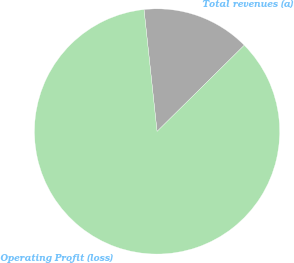<chart> <loc_0><loc_0><loc_500><loc_500><pie_chart><fcel>Total revenues (a)<fcel>Operating Profit (loss)<nl><fcel>14.29%<fcel>85.71%<nl></chart> 